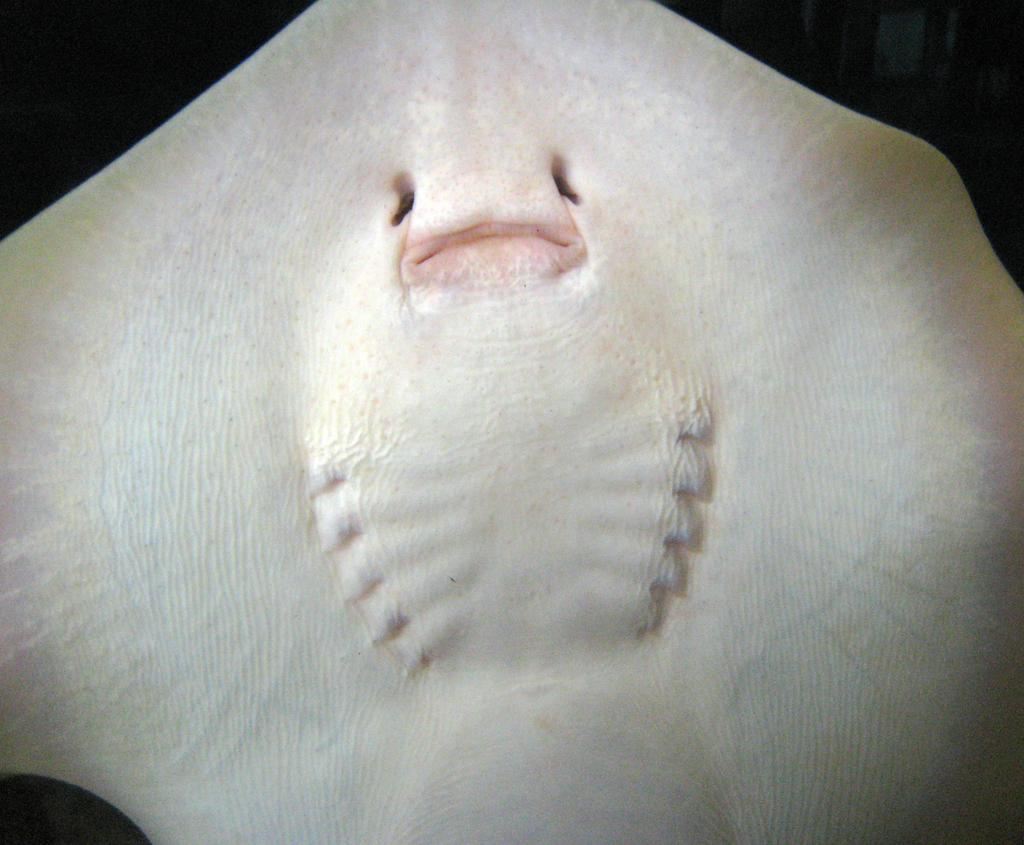What type of animal is in the image? There is a white color fish in the image. What can be observed about the background of the image? The background of the image is dark in color. What type of relation does the fish have with the cover in the image? There is no cover present in the image, so the fish does not have a relation with a cover. 